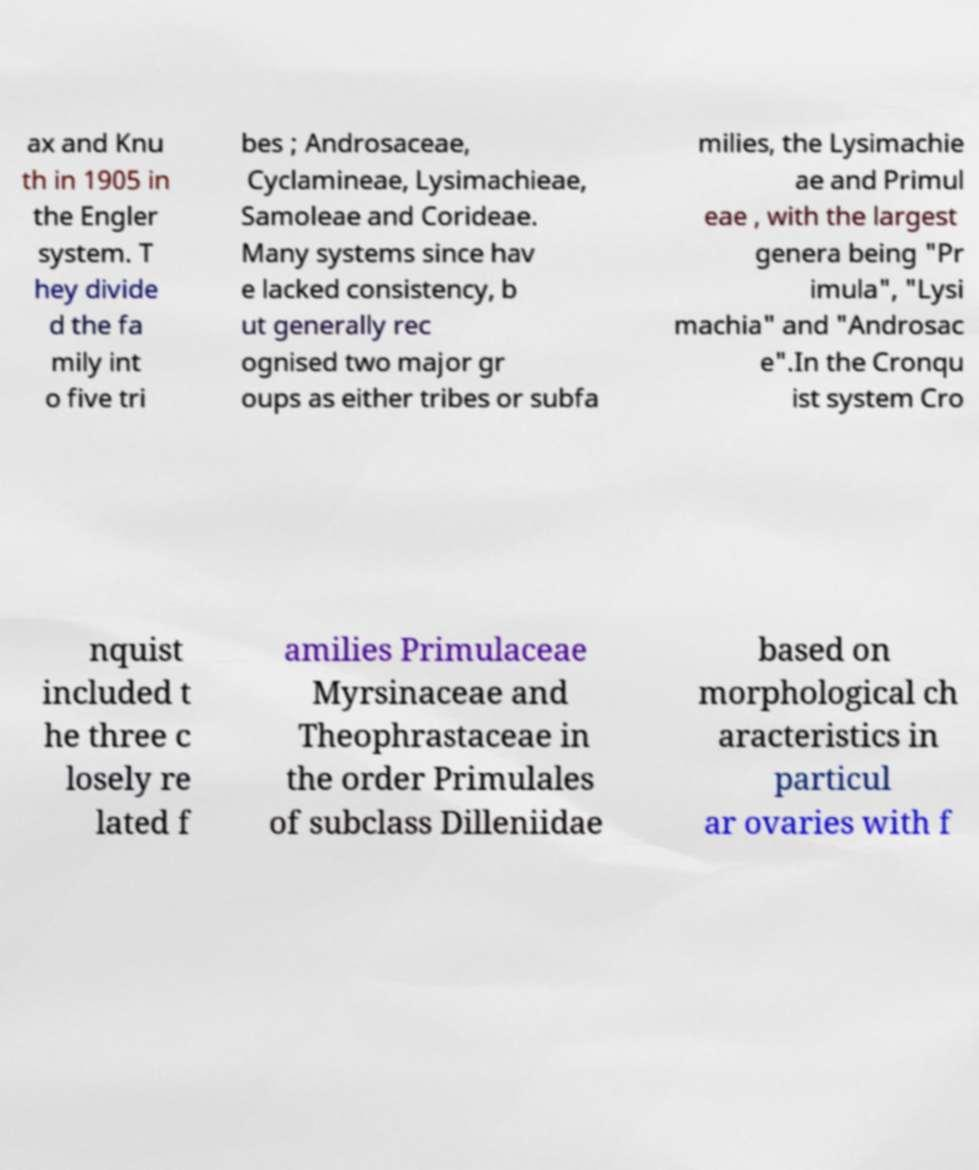I need the written content from this picture converted into text. Can you do that? ax and Knu th in 1905 in the Engler system. T hey divide d the fa mily int o five tri bes ; Androsaceae, Cyclamineae, Lysimachieae, Samoleae and Corideae. Many systems since hav e lacked consistency, b ut generally rec ognised two major gr oups as either tribes or subfa milies, the Lysimachie ae and Primul eae , with the largest genera being "Pr imula", "Lysi machia" and "Androsac e".In the Cronqu ist system Cro nquist included t he three c losely re lated f amilies Primulaceae Myrsinaceae and Theophrastaceae in the order Primulales of subclass Dilleniidae based on morphological ch aracteristics in particul ar ovaries with f 